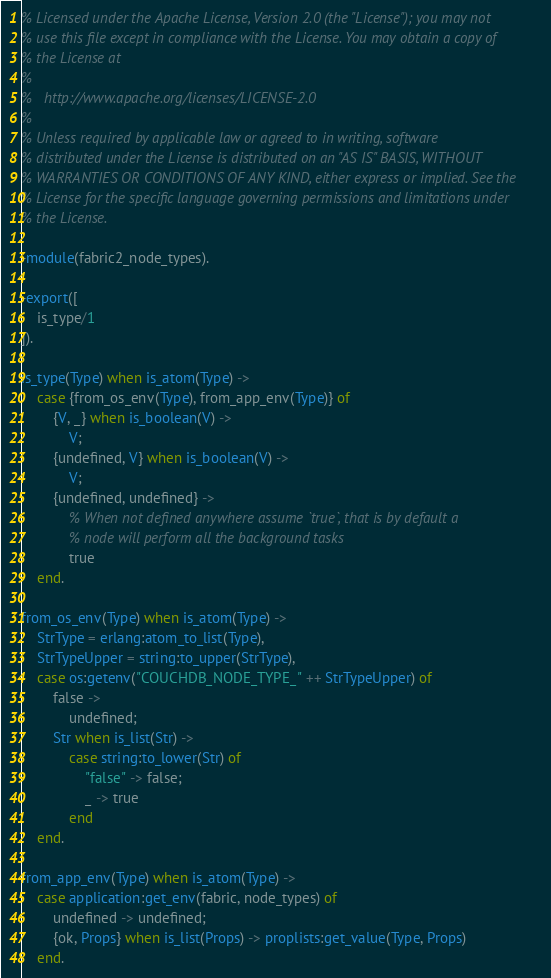Convert code to text. <code><loc_0><loc_0><loc_500><loc_500><_Erlang_>% Licensed under the Apache License, Version 2.0 (the "License"); you may not
% use this file except in compliance with the License. You may obtain a copy of
% the License at
%
%   http://www.apache.org/licenses/LICENSE-2.0
%
% Unless required by applicable law or agreed to in writing, software
% distributed under the License is distributed on an "AS IS" BASIS, WITHOUT
% WARRANTIES OR CONDITIONS OF ANY KIND, either express or implied. See the
% License for the specific language governing permissions and limitations under
% the License.

-module(fabric2_node_types).

-export([
    is_type/1
]).

is_type(Type) when is_atom(Type) ->
    case {from_os_env(Type), from_app_env(Type)} of
        {V, _} when is_boolean(V) ->
            V;
        {undefined, V} when is_boolean(V) ->
            V;
        {undefined, undefined} ->
            % When not defined anywhere assume `true`, that is by default a
            % node will perform all the background tasks
            true
    end.

from_os_env(Type) when is_atom(Type) ->
    StrType = erlang:atom_to_list(Type),
    StrTypeUpper = string:to_upper(StrType),
    case os:getenv("COUCHDB_NODE_TYPE_" ++ StrTypeUpper) of
        false ->
            undefined;
        Str when is_list(Str) ->
            case string:to_lower(Str) of
                "false" -> false;
                _ -> true
            end
    end.

from_app_env(Type) when is_atom(Type) ->
    case application:get_env(fabric, node_types) of
        undefined -> undefined;
        {ok, Props} when is_list(Props) -> proplists:get_value(Type, Props)
    end.
</code> 